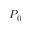Convert formula to latex. <formula><loc_0><loc_0><loc_500><loc_500>P _ { 0 }</formula> 